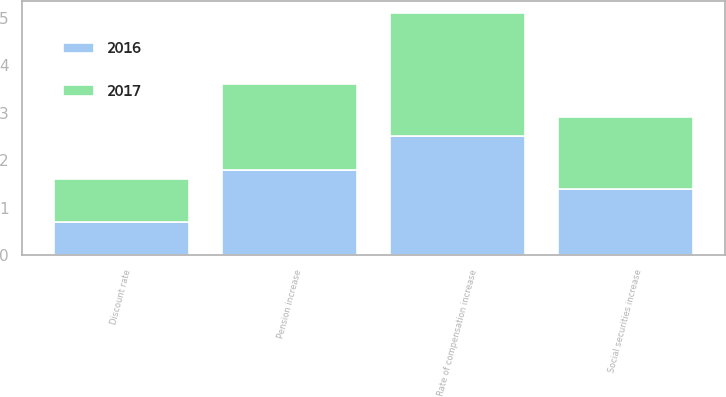Convert chart. <chart><loc_0><loc_0><loc_500><loc_500><stacked_bar_chart><ecel><fcel>Discount rate<fcel>Rate of compensation increase<fcel>Social securities increase<fcel>Pension increase<nl><fcel>2017<fcel>0.9<fcel>2.6<fcel>1.5<fcel>1.8<nl><fcel>2016<fcel>0.7<fcel>2.5<fcel>1.4<fcel>1.8<nl></chart> 